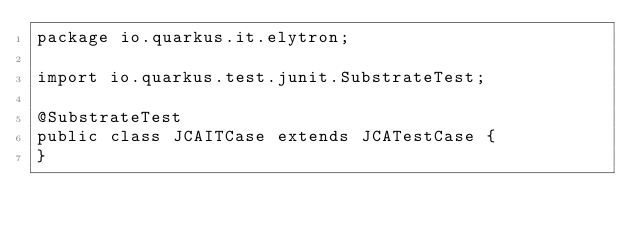<code> <loc_0><loc_0><loc_500><loc_500><_Java_>package io.quarkus.it.elytron;

import io.quarkus.test.junit.SubstrateTest;

@SubstrateTest
public class JCAITCase extends JCATestCase {
}
</code> 